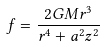Convert formula to latex. <formula><loc_0><loc_0><loc_500><loc_500>f = { \frac { 2 G M r ^ { 3 } } { r ^ { 4 } + a ^ { 2 } z ^ { 2 } } }</formula> 